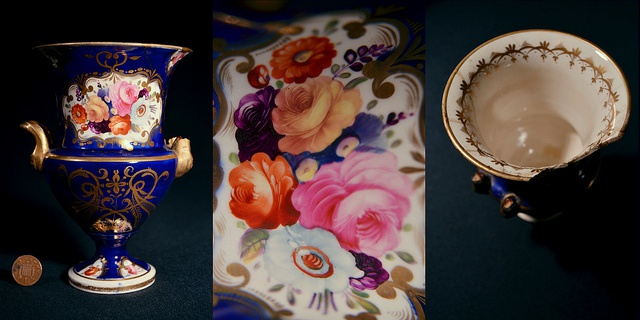Describe the objects in this image and their specific colors. I can see vase in black, darkgray, brown, and maroon tones, vase in black, gray, darkgray, and tan tones, and vase in black, navy, beige, and maroon tones in this image. 